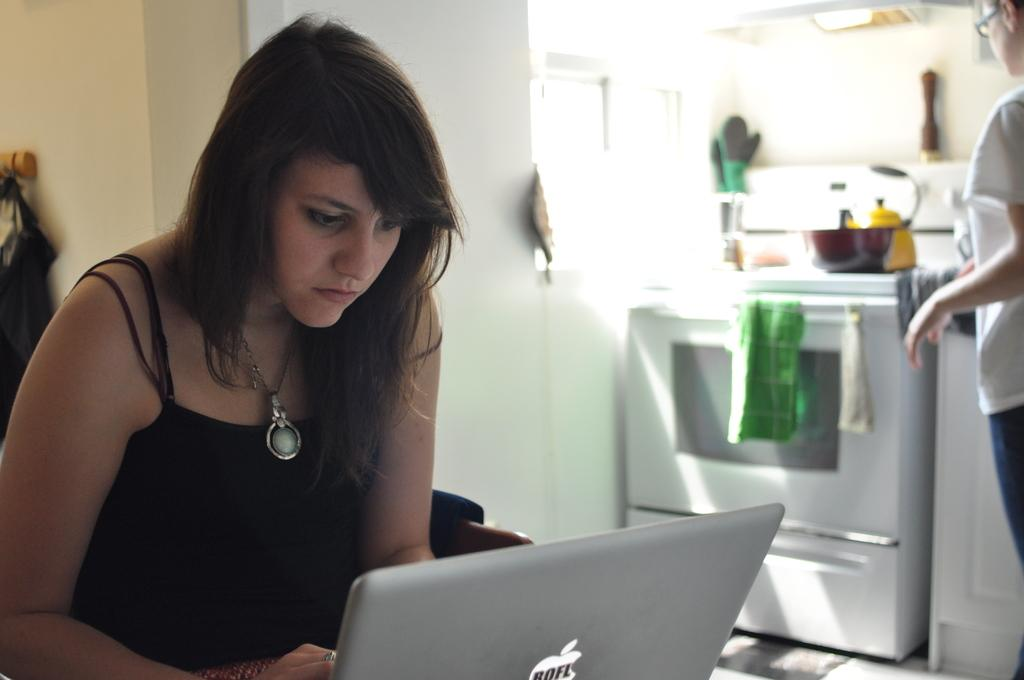<image>
Write a terse but informative summary of the picture. A women wearing a necklace is using an Apple laptop in a kitchen. 